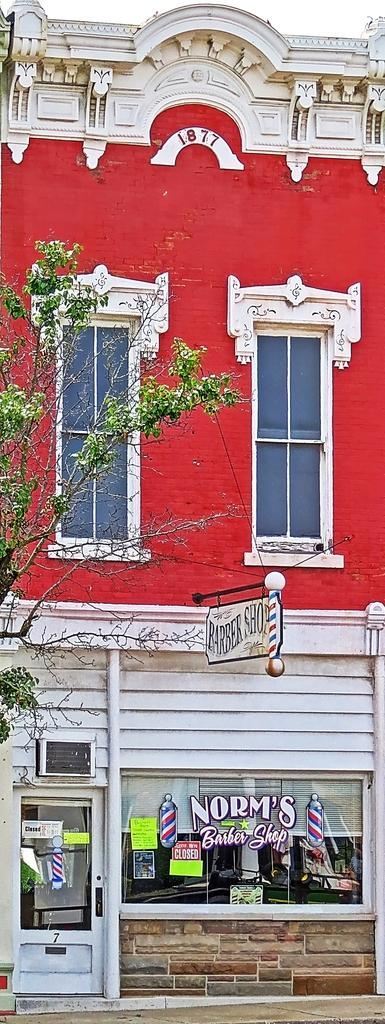What type of structure can be seen in the image? There is a building in the image. What natural element is present in the image? There is a tree in the image. How many lips can be seen on the tree in the image? There are no lips present in the image, as it features a building and a tree. Are there any chickens visible in the image? There is no mention of chickens in the provided facts, and therefore it cannot be determined if they are present in the image. 